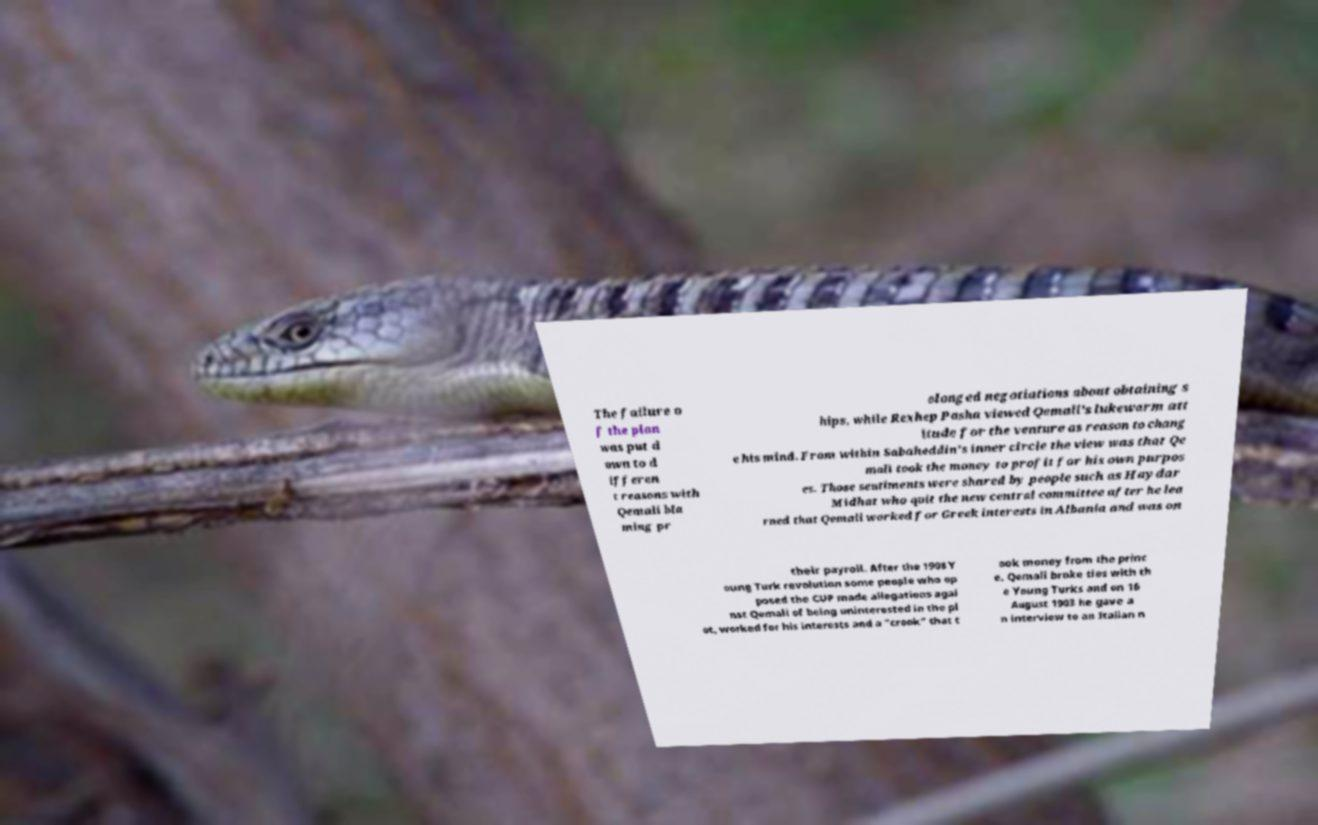Please read and relay the text visible in this image. What does it say? The failure o f the plan was put d own to d ifferen t reasons with Qemali bla ming pr olonged negotiations about obtaining s hips, while Rexhep Pasha viewed Qemali's lukewarm att itude for the venture as reason to chang e his mind. From within Sabaheddin's inner circle the view was that Qe mali took the money to profit for his own purpos es. Those sentiments were shared by people such as Haydar Midhat who quit the new central committee after he lea rned that Qemali worked for Greek interests in Albania and was on their payroll. After the 1908 Y oung Turk revolution some people who op posed the CUP made allegations agai nst Qemali of being uninterested in the pl ot, worked for his interests and a "crook" that t ook money from the princ e. Qemali broke ties with th e Young Turks and on 16 August 1903 he gave a n interview to an Italian n 